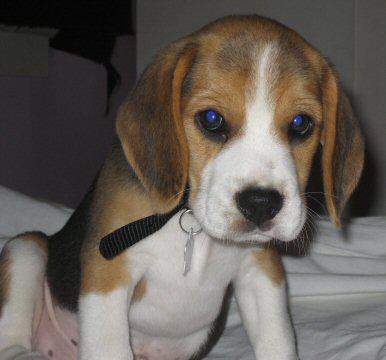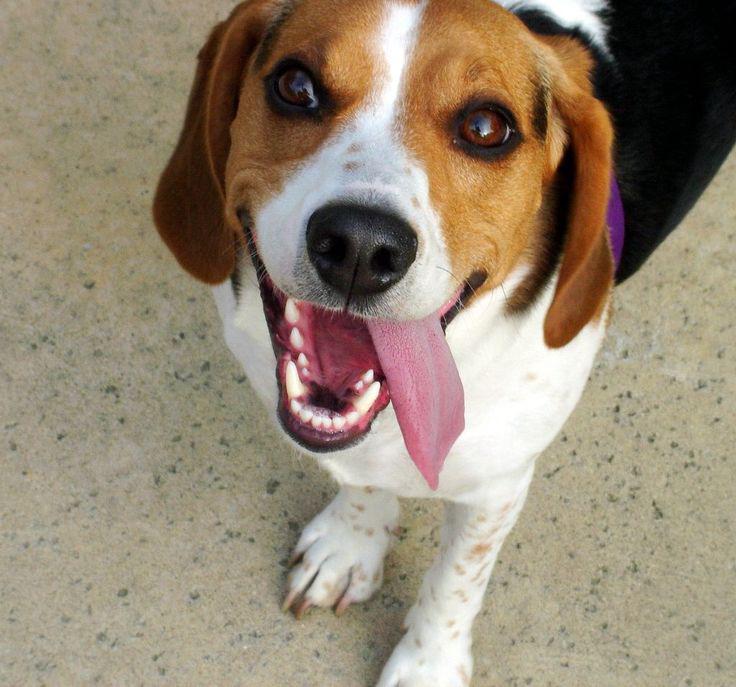The first image is the image on the left, the second image is the image on the right. Given the left and right images, does the statement "A dog has its tongue visible while looking at the camera." hold true? Answer yes or no. Yes. The first image is the image on the left, the second image is the image on the right. For the images shown, is this caption "Right image shows a camera-facing beagle with its tongue at least partly showing." true? Answer yes or no. Yes. 